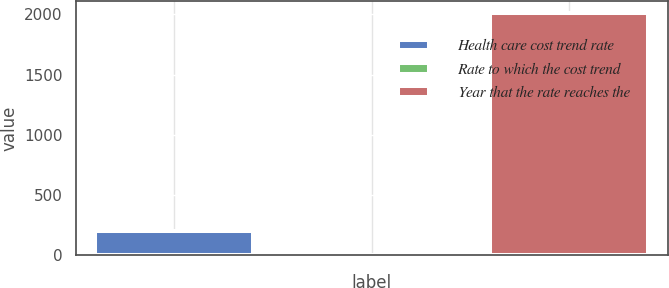Convert chart to OTSL. <chart><loc_0><loc_0><loc_500><loc_500><bar_chart><fcel>Health care cost trend rate<fcel>Rate to which the cost trend<fcel>Year that the rate reaches the<nl><fcel>205.03<fcel>4.48<fcel>2010<nl></chart> 